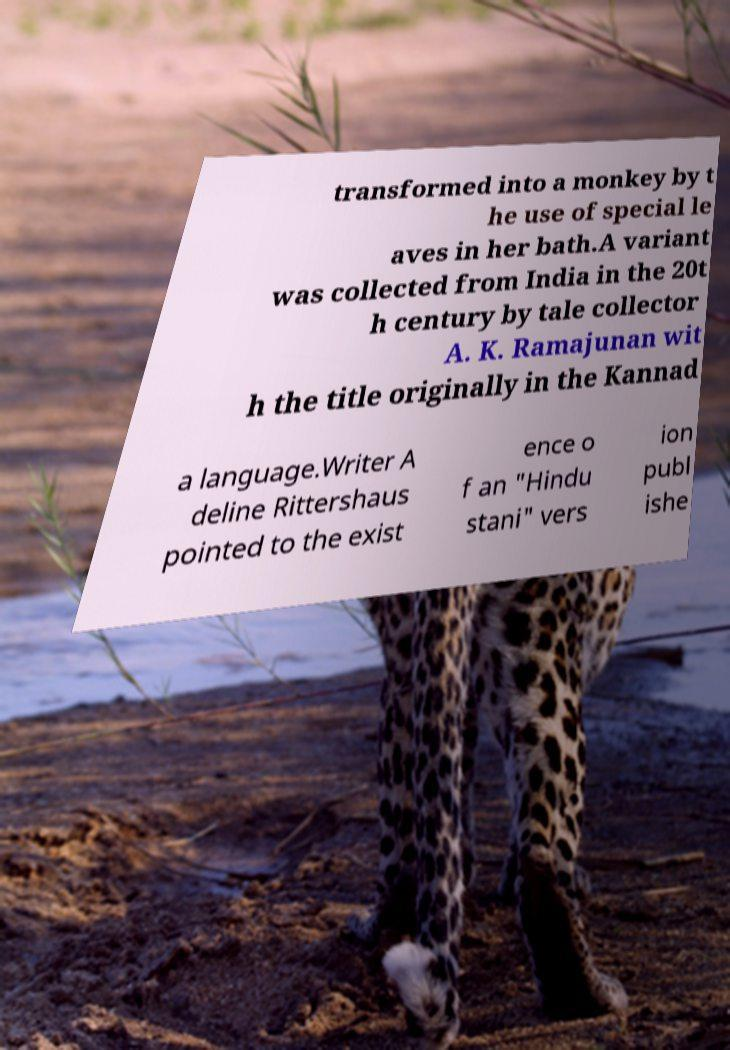For documentation purposes, I need the text within this image transcribed. Could you provide that? transformed into a monkey by t he use of special le aves in her bath.A variant was collected from India in the 20t h century by tale collector A. K. Ramajunan wit h the title originally in the Kannad a language.Writer A deline Rittershaus pointed to the exist ence o f an "Hindu stani" vers ion publ ishe 